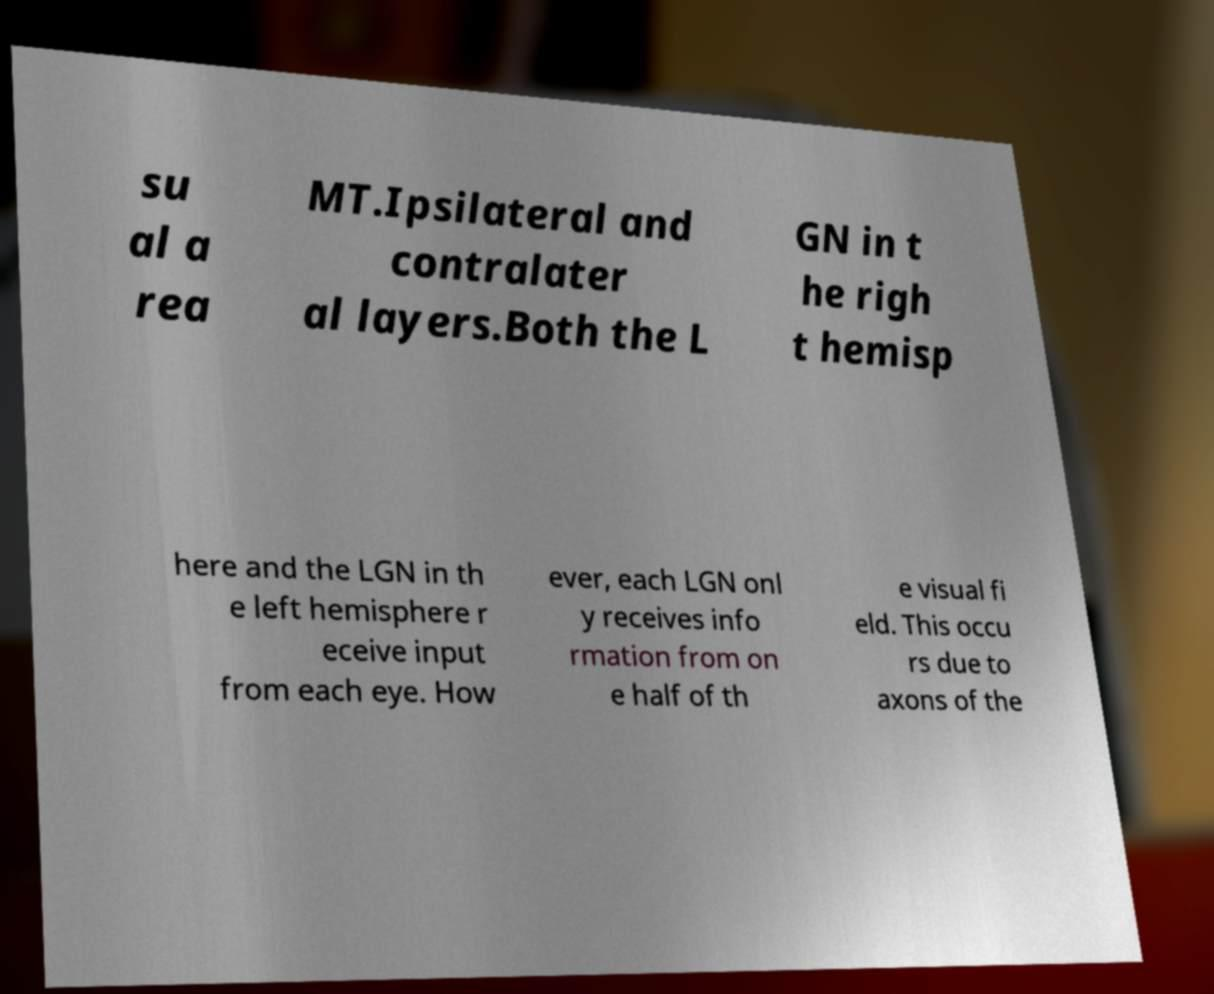Could you assist in decoding the text presented in this image and type it out clearly? su al a rea MT.Ipsilateral and contralater al layers.Both the L GN in t he righ t hemisp here and the LGN in th e left hemisphere r eceive input from each eye. How ever, each LGN onl y receives info rmation from on e half of th e visual fi eld. This occu rs due to axons of the 